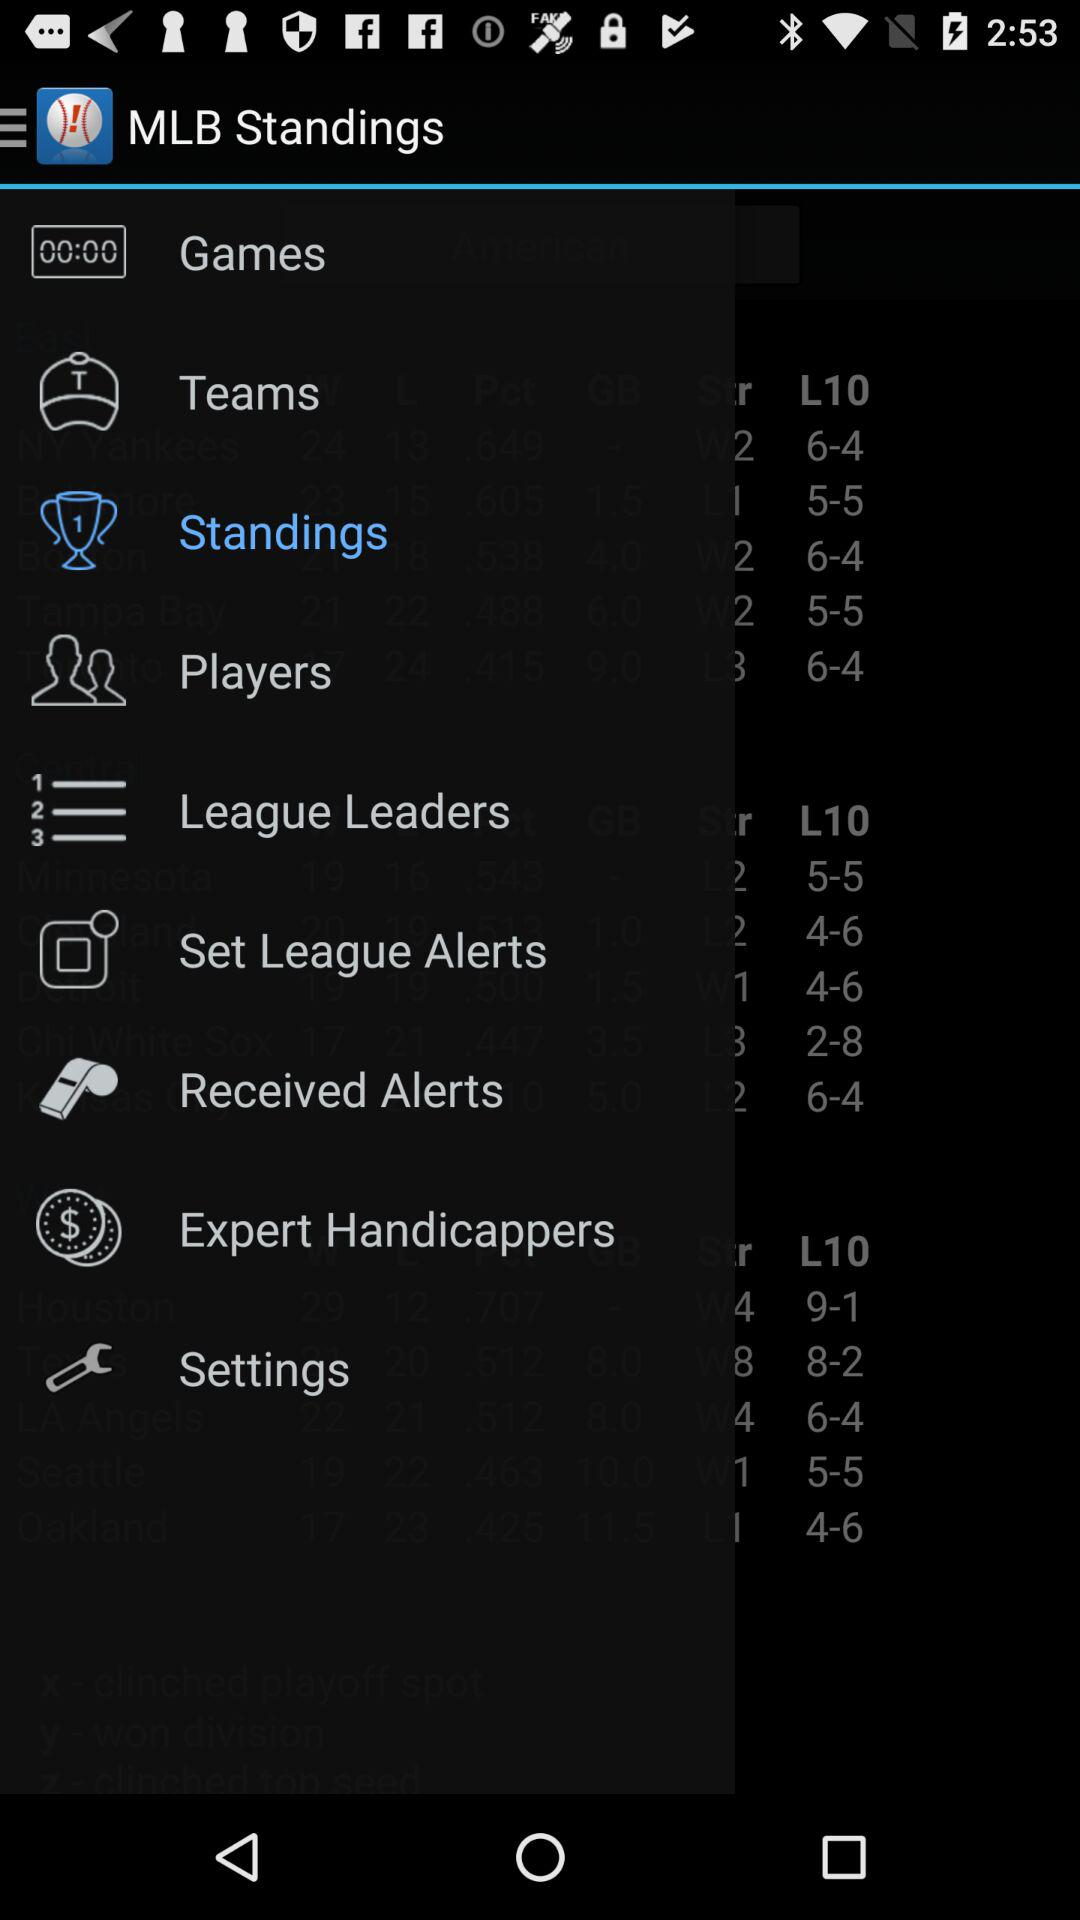What MLB Standings option is highlighted? The highlighted option is "Standings". 